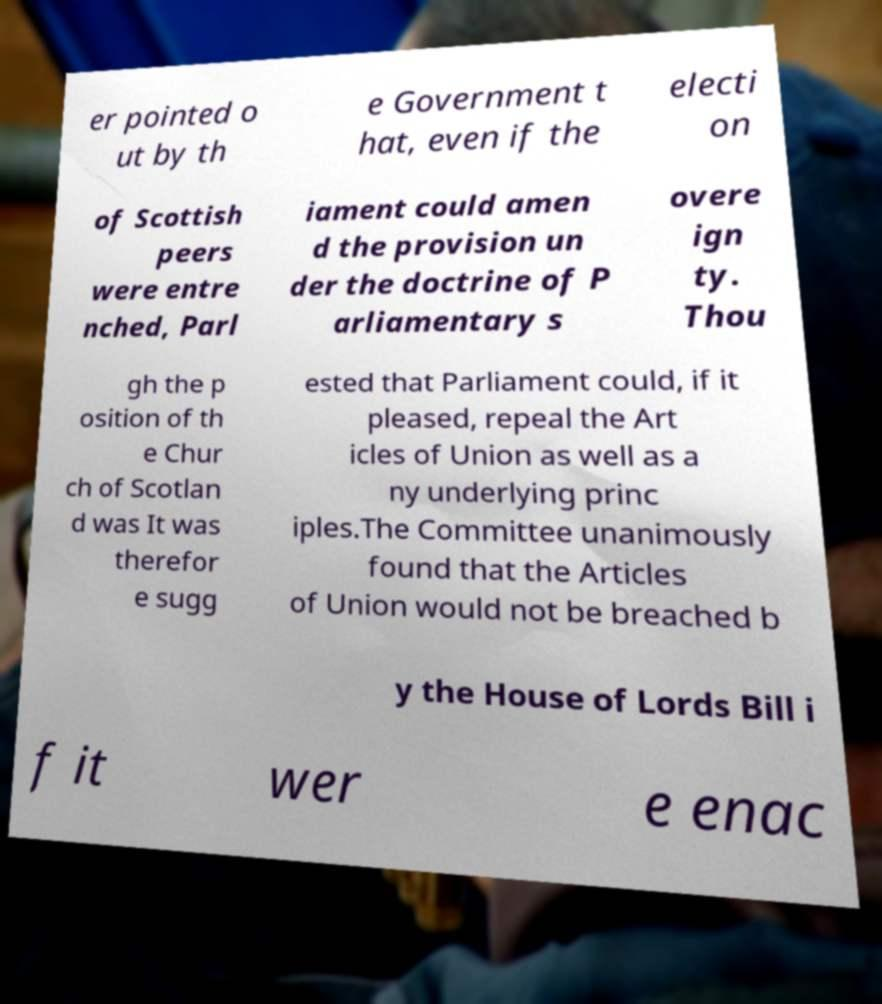Could you extract and type out the text from this image? er pointed o ut by th e Government t hat, even if the electi on of Scottish peers were entre nched, Parl iament could amen d the provision un der the doctrine of P arliamentary s overe ign ty. Thou gh the p osition of th e Chur ch of Scotlan d was It was therefor e sugg ested that Parliament could, if it pleased, repeal the Art icles of Union as well as a ny underlying princ iples.The Committee unanimously found that the Articles of Union would not be breached b y the House of Lords Bill i f it wer e enac 